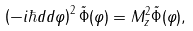<formula> <loc_0><loc_0><loc_500><loc_500>\left ( - i \hbar { } { d } { d \varphi } \right ) ^ { 2 } \tilde { \Phi } ( \varphi ) = M _ { z } ^ { 2 } \tilde { \Phi } ( \varphi ) ,</formula> 